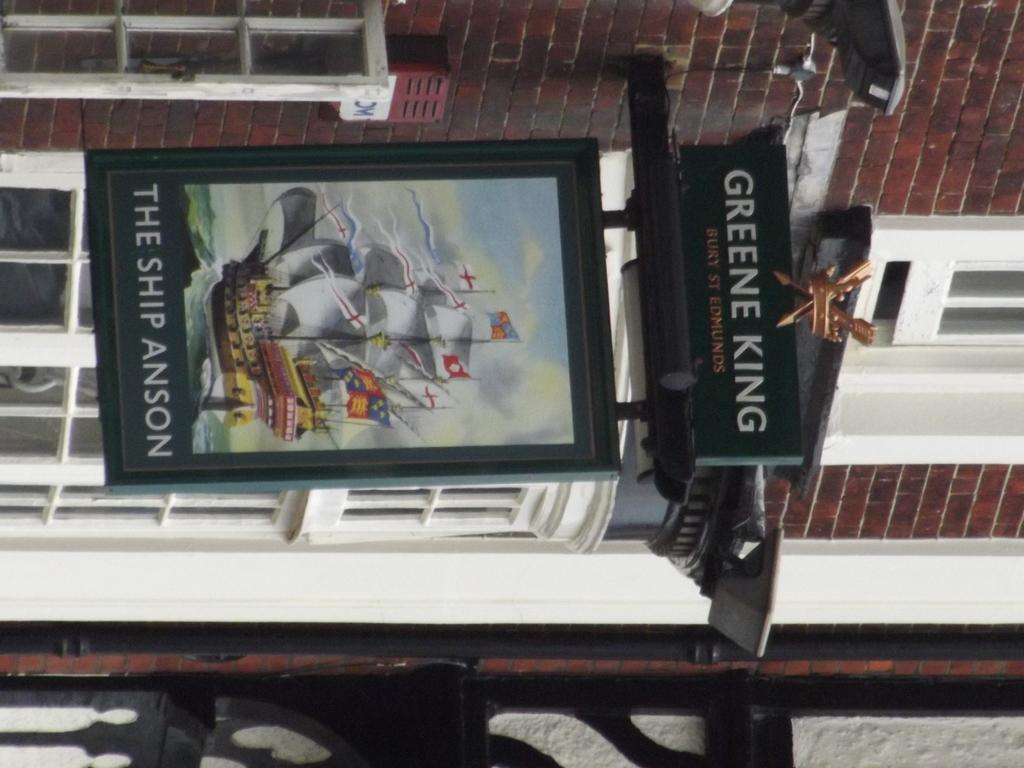<image>
Give a short and clear explanation of the subsequent image. Sign for a restaurant that says The Ship Anson. 